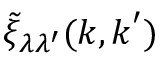<formula> <loc_0><loc_0><loc_500><loc_500>\tilde { \xi } _ { \lambda \lambda ^ { \prime } } ( k , k ^ { \prime } )</formula> 